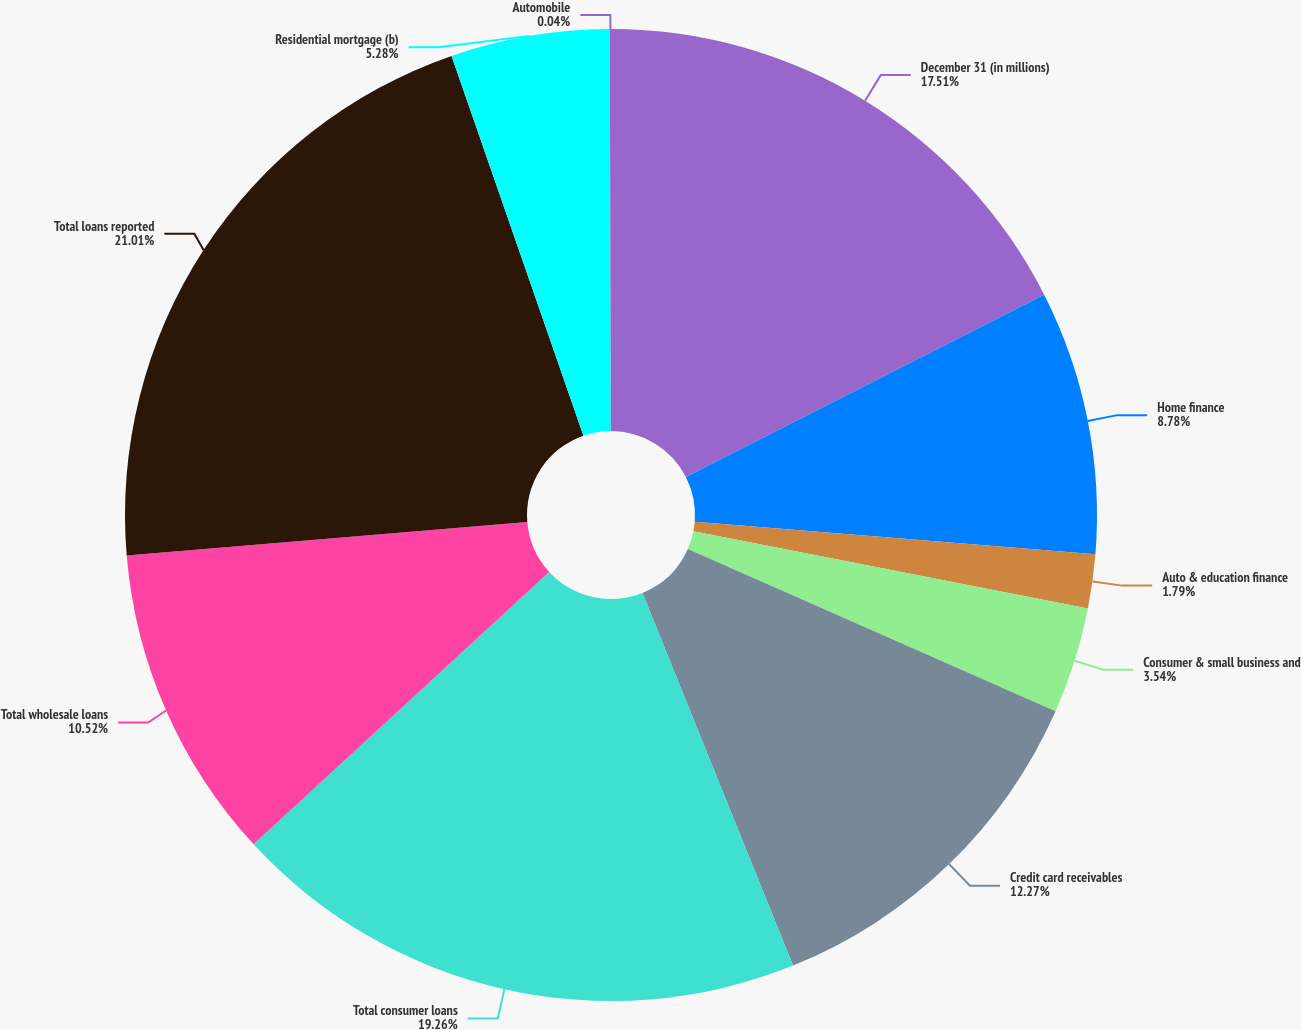Convert chart. <chart><loc_0><loc_0><loc_500><loc_500><pie_chart><fcel>December 31 (in millions)<fcel>Home finance<fcel>Auto & education finance<fcel>Consumer & small business and<fcel>Credit card receivables<fcel>Total consumer loans<fcel>Total wholesale loans<fcel>Total loans reported<fcel>Residential mortgage (b)<fcel>Automobile<nl><fcel>17.51%<fcel>8.78%<fcel>1.79%<fcel>3.54%<fcel>12.27%<fcel>19.26%<fcel>10.52%<fcel>21.01%<fcel>5.28%<fcel>0.04%<nl></chart> 